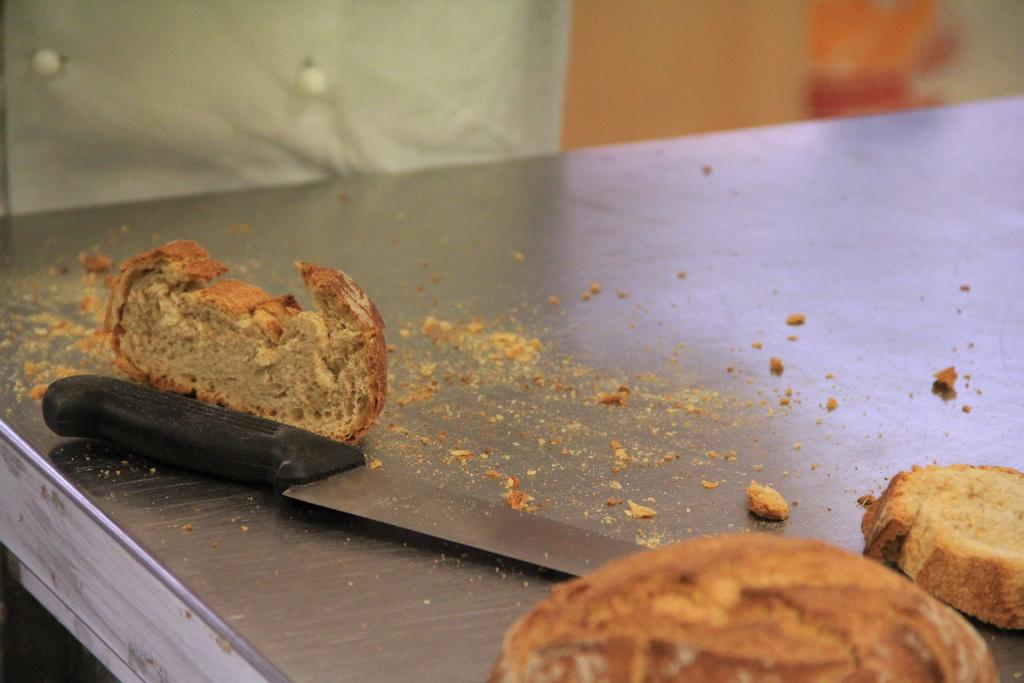What is located in the center of the image? There is a table in the center of the image. What type of food can be seen on the table? Breads are present on the table. What utensil is placed on the table? A knife is placed on the table. What can be seen in the background of the image? There is a cloth and a wall in the background of the image. What type of brush is being used to play with the gun in the image? There is no brush or gun present in the image; it features a table with breads, a knife, a cloth, and a wall in the background. 